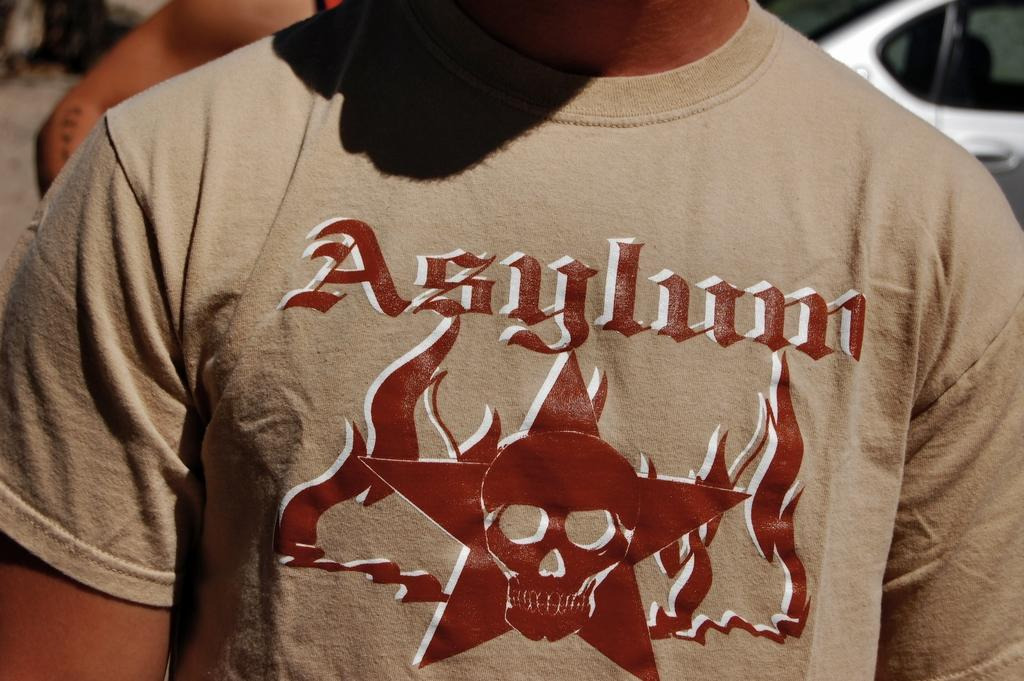<image>
Provide a brief description of the given image. A tshirt with a skull image and the word Asylum on it. 